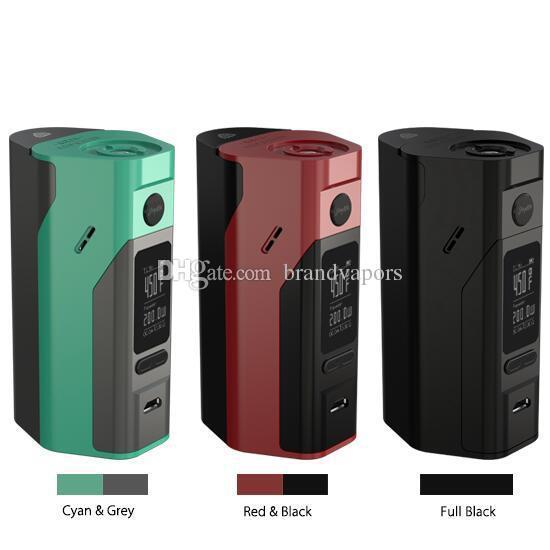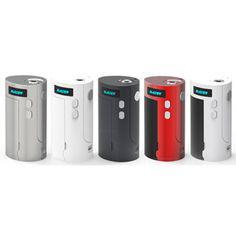The first image is the image on the left, the second image is the image on the right. Examine the images to the left and right. Is the description "The right image contains exactly four vape devices." accurate? Answer yes or no. No. The first image is the image on the left, the second image is the image on the right. Analyze the images presented: Is the assertion "The same number of phones, each sporting a distinct color design, is in each image." valid? Answer yes or no. No. 